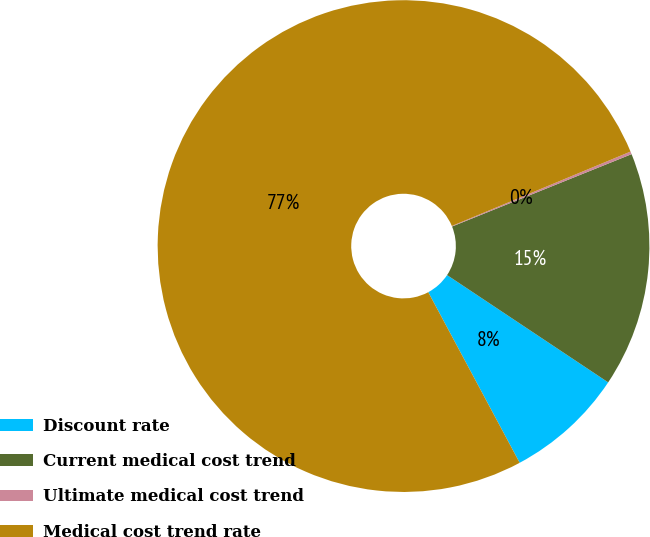Convert chart. <chart><loc_0><loc_0><loc_500><loc_500><pie_chart><fcel>Discount rate<fcel>Current medical cost trend<fcel>Ultimate medical cost trend<fcel>Medical cost trend rate<nl><fcel>7.82%<fcel>15.45%<fcel>0.18%<fcel>76.55%<nl></chart> 